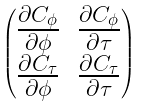<formula> <loc_0><loc_0><loc_500><loc_500>\begin{pmatrix} \frac { \partial C _ { \phi } } { \partial \phi } & \frac { \partial C _ { \phi } } { \partial \tau } \\ \frac { \partial C _ { \tau } } { \partial \phi } & \frac { \partial C _ { \tau } } { \partial \tau } \end{pmatrix}</formula> 